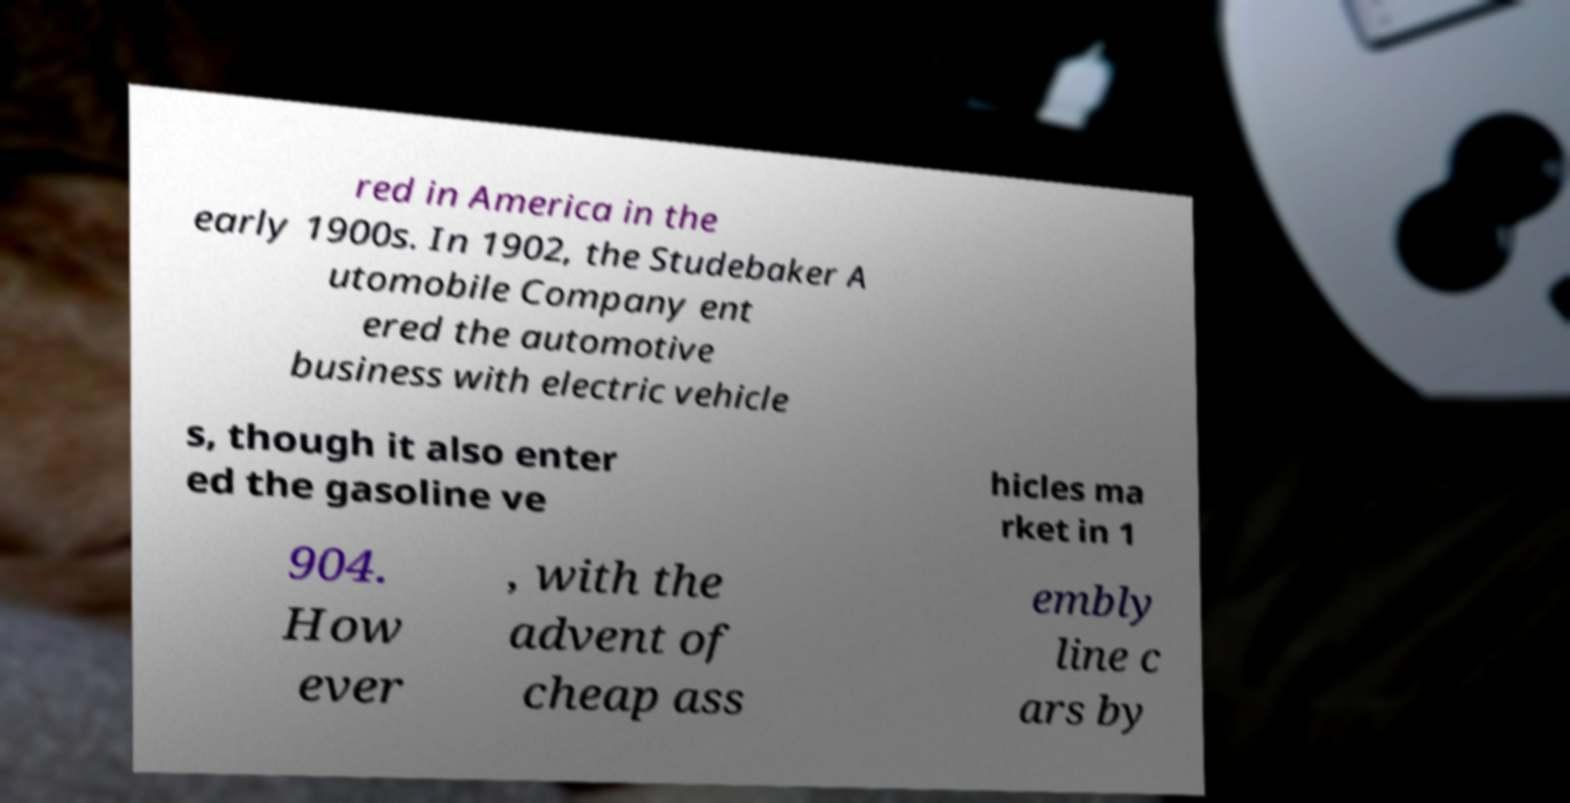Can you accurately transcribe the text from the provided image for me? red in America in the early 1900s. In 1902, the Studebaker A utomobile Company ent ered the automotive business with electric vehicle s, though it also enter ed the gasoline ve hicles ma rket in 1 904. How ever , with the advent of cheap ass embly line c ars by 